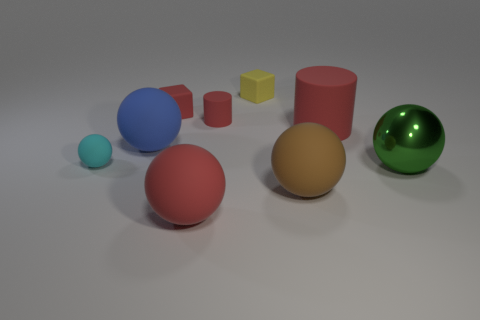Subtract 1 spheres. How many spheres are left? 4 Subtract all cyan balls. How many balls are left? 4 Subtract all red spheres. How many spheres are left? 4 Subtract all yellow spheres. Subtract all cyan blocks. How many spheres are left? 5 Add 1 tiny red blocks. How many objects exist? 10 Subtract all spheres. How many objects are left? 4 Subtract all yellow shiny things. Subtract all yellow rubber cubes. How many objects are left? 8 Add 5 big matte balls. How many big matte balls are left? 8 Add 8 large metal spheres. How many large metal spheres exist? 9 Subtract 1 brown spheres. How many objects are left? 8 